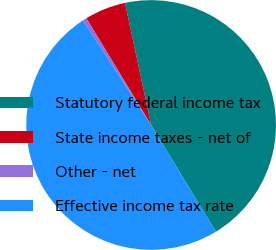Convert chart to OTSL. <chart><loc_0><loc_0><loc_500><loc_500><pie_chart><fcel>Statutory federal income tax<fcel>State income taxes - net of<fcel>Other - net<fcel>Effective income tax rate<nl><fcel>44.67%<fcel>5.33%<fcel>0.51%<fcel>49.49%<nl></chart> 